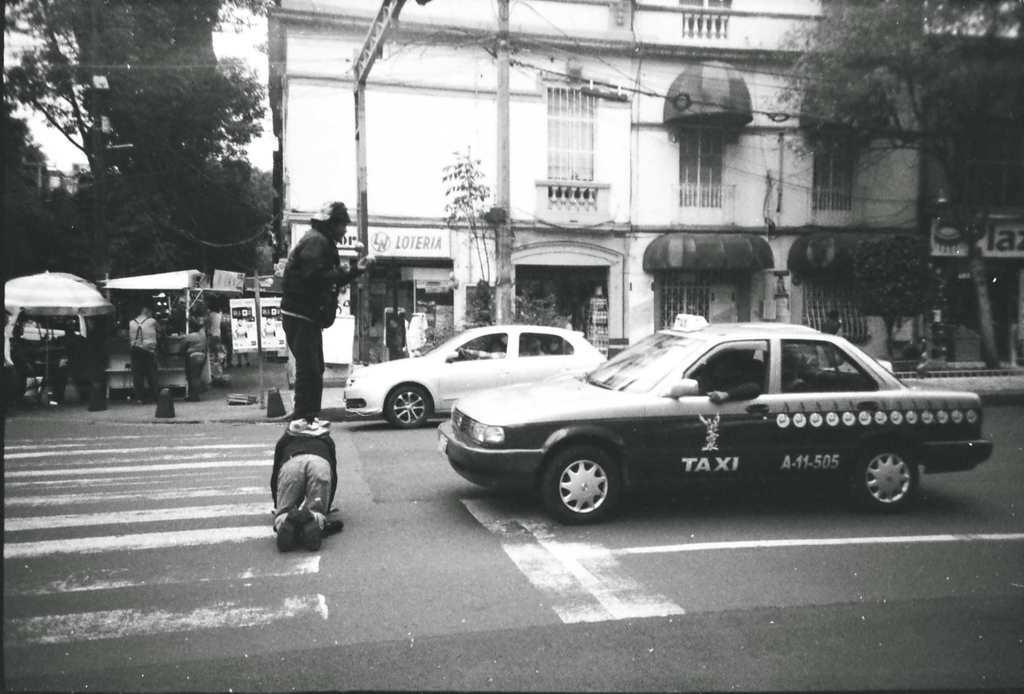<image>
Give a short and clear explanation of the subsequent image. Man is riding on top of an other man in front of a vehicle that says TAXI. 